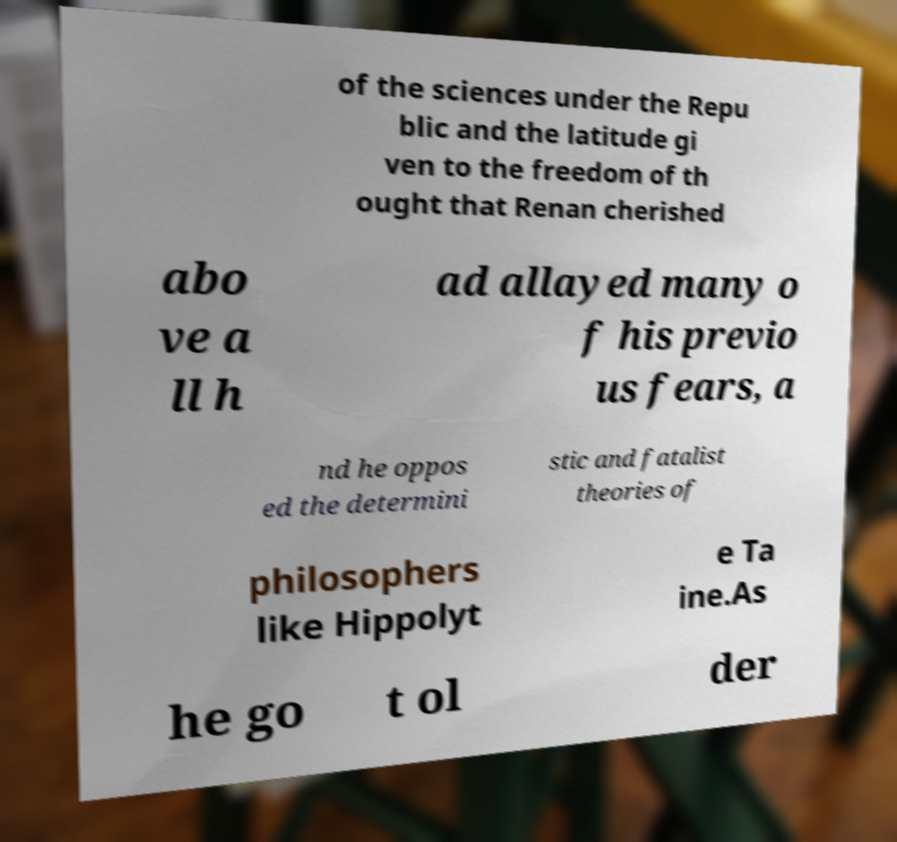What messages or text are displayed in this image? I need them in a readable, typed format. of the sciences under the Repu blic and the latitude gi ven to the freedom of th ought that Renan cherished abo ve a ll h ad allayed many o f his previo us fears, a nd he oppos ed the determini stic and fatalist theories of philosophers like Hippolyt e Ta ine.As he go t ol der 